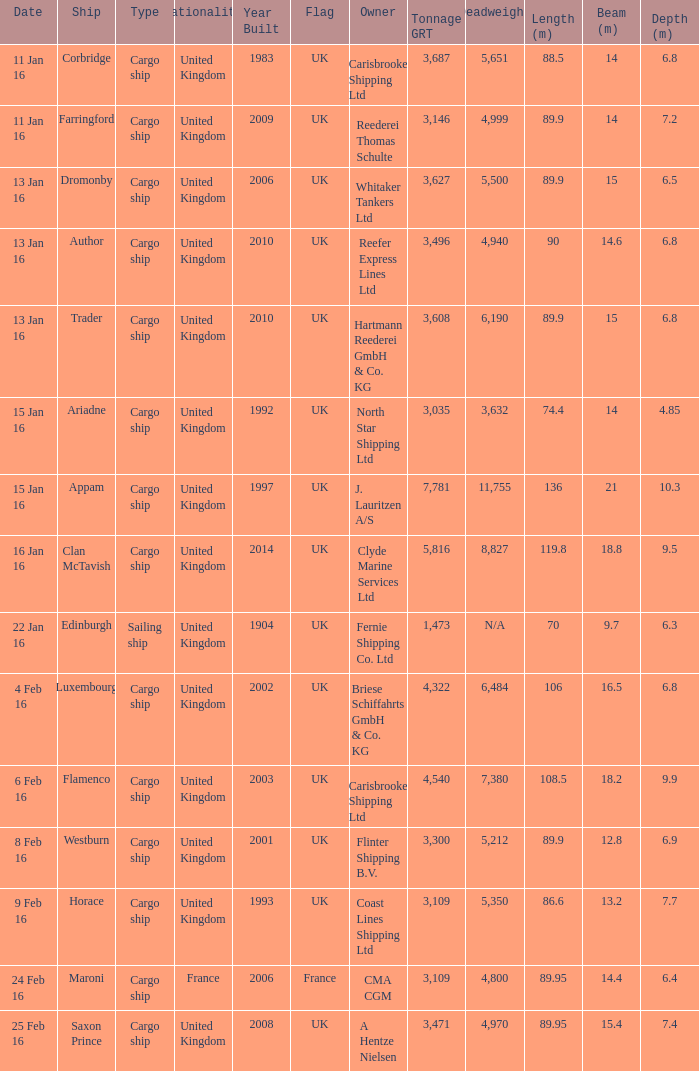What is the combined gross registered tonnage of the cargo ship(s) seized or sunk on 4th february 16? 1.0. 